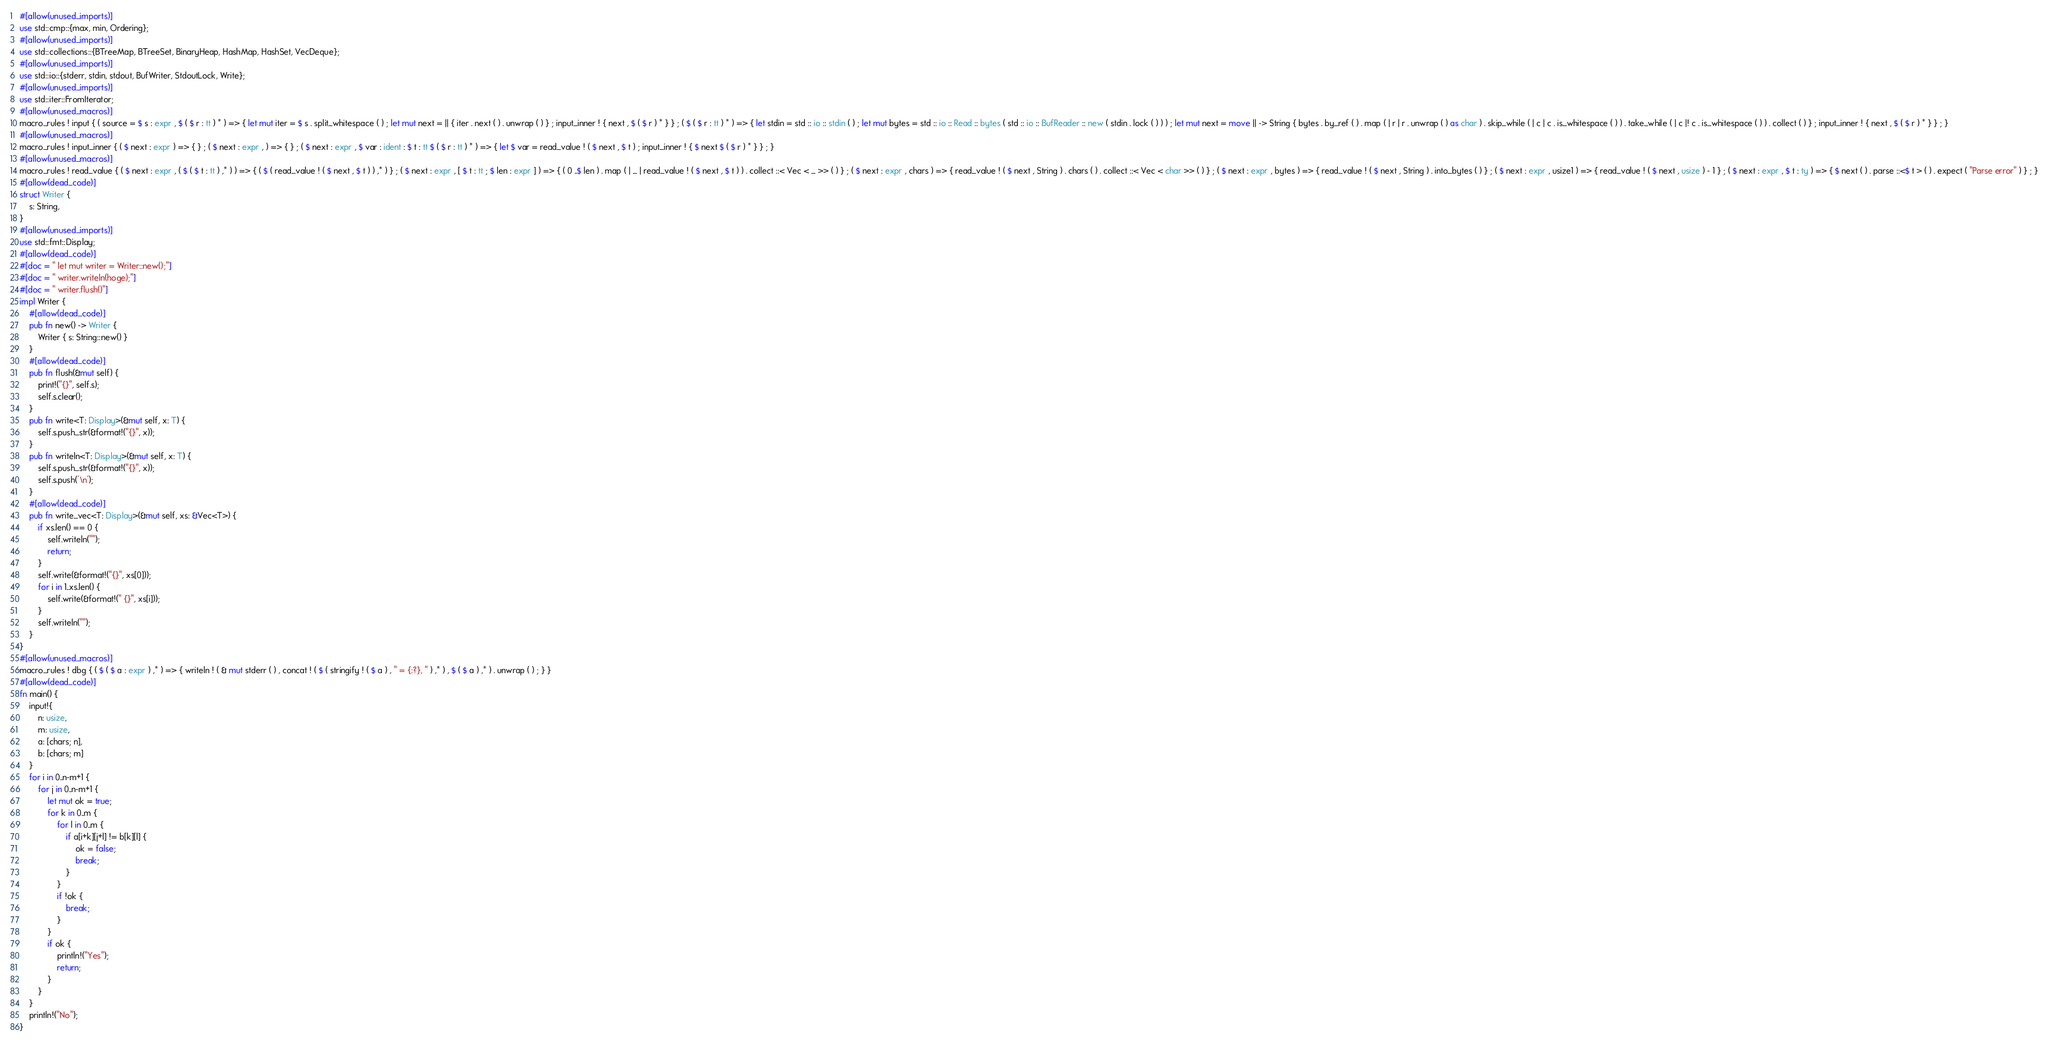Convert code to text. <code><loc_0><loc_0><loc_500><loc_500><_Rust_>#[allow(unused_imports)]
use std::cmp::{max, min, Ordering};
#[allow(unused_imports)]
use std::collections::{BTreeMap, BTreeSet, BinaryHeap, HashMap, HashSet, VecDeque};
#[allow(unused_imports)]
use std::io::{stderr, stdin, stdout, BufWriter, StdoutLock, Write};
#[allow(unused_imports)]
use std::iter::FromIterator;
#[allow(unused_macros)]
macro_rules ! input { ( source = $ s : expr , $ ( $ r : tt ) * ) => { let mut iter = $ s . split_whitespace ( ) ; let mut next = || { iter . next ( ) . unwrap ( ) } ; input_inner ! { next , $ ( $ r ) * } } ; ( $ ( $ r : tt ) * ) => { let stdin = std :: io :: stdin ( ) ; let mut bytes = std :: io :: Read :: bytes ( std :: io :: BufReader :: new ( stdin . lock ( ) ) ) ; let mut next = move || -> String { bytes . by_ref ( ) . map ( | r | r . unwrap ( ) as char ) . skip_while ( | c | c . is_whitespace ( ) ) . take_while ( | c |! c . is_whitespace ( ) ) . collect ( ) } ; input_inner ! { next , $ ( $ r ) * } } ; }
#[allow(unused_macros)]
macro_rules ! input_inner { ( $ next : expr ) => { } ; ( $ next : expr , ) => { } ; ( $ next : expr , $ var : ident : $ t : tt $ ( $ r : tt ) * ) => { let $ var = read_value ! ( $ next , $ t ) ; input_inner ! { $ next $ ( $ r ) * } } ; }
#[allow(unused_macros)]
macro_rules ! read_value { ( $ next : expr , ( $ ( $ t : tt ) ,* ) ) => { ( $ ( read_value ! ( $ next , $ t ) ) ,* ) } ; ( $ next : expr , [ $ t : tt ; $ len : expr ] ) => { ( 0 ..$ len ) . map ( | _ | read_value ! ( $ next , $ t ) ) . collect ::< Vec < _ >> ( ) } ; ( $ next : expr , chars ) => { read_value ! ( $ next , String ) . chars ( ) . collect ::< Vec < char >> ( ) } ; ( $ next : expr , bytes ) => { read_value ! ( $ next , String ) . into_bytes ( ) } ; ( $ next : expr , usize1 ) => { read_value ! ( $ next , usize ) - 1 } ; ( $ next : expr , $ t : ty ) => { $ next ( ) . parse ::<$ t > ( ) . expect ( "Parse error" ) } ; }
#[allow(dead_code)]
struct Writer {
    s: String,
}
#[allow(unused_imports)]
use std::fmt::Display;
#[allow(dead_code)]
#[doc = " let mut writer = Writer::new();"]
#[doc = " writer.writeln(hoge);"]
#[doc = " writer.flush()"]
impl Writer {
    #[allow(dead_code)]
    pub fn new() -> Writer {
        Writer { s: String::new() }
    }
    #[allow(dead_code)]
    pub fn flush(&mut self) {
        print!("{}", self.s);
        self.s.clear();
    }
    pub fn write<T: Display>(&mut self, x: T) {
        self.s.push_str(&format!("{}", x));
    }
    pub fn writeln<T: Display>(&mut self, x: T) {
        self.s.push_str(&format!("{}", x));
        self.s.push('\n');
    }
    #[allow(dead_code)]
    pub fn write_vec<T: Display>(&mut self, xs: &Vec<T>) {
        if xs.len() == 0 {
            self.writeln("");
            return;
        }
        self.write(&format!("{}", xs[0]));
        for i in 1..xs.len() {
            self.write(&format!(" {}", xs[i]));
        }
        self.writeln("");
    }
}
#[allow(unused_macros)]
macro_rules ! dbg { ( $ ( $ a : expr ) ,* ) => { writeln ! ( & mut stderr ( ) , concat ! ( $ ( stringify ! ( $ a ) , " = {:?}, " ) ,* ) , $ ( $ a ) ,* ) . unwrap ( ) ; } }
#[allow(dead_code)]
fn main() {
    input!{
        n: usize,
        m: usize,
        a: [chars; n],
        b: [chars; m]
    }
    for i in 0..n-m+1 {
        for j in 0..n-m+1 {
            let mut ok = true;
            for k in 0..m {
                for l in 0..m {
                    if a[i+k][j+l] != b[k][l] {
                        ok = false;
                        break;
                    }
                }
                if !ok {
                    break;
                }
            }
            if ok {
                println!("Yes");
                return;
            }
        }
    }
    println!("No");
}</code> 